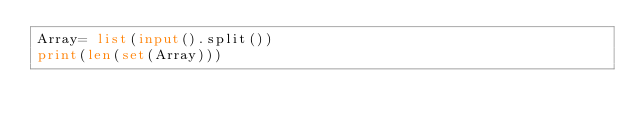Convert code to text. <code><loc_0><loc_0><loc_500><loc_500><_Python_>Array= list(input().split())
print(len(set(Array)))</code> 